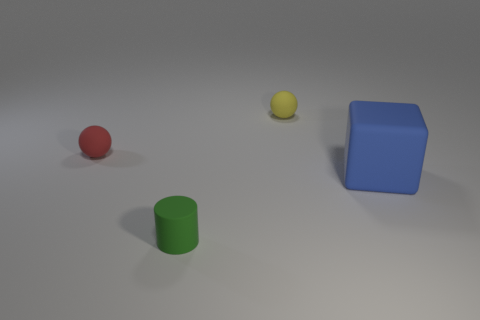What number of other things are there of the same size as the red sphere?
Your answer should be very brief. 2. How many small yellow rubber objects are there?
Provide a succinct answer. 1. Is the size of the red matte object the same as the yellow rubber object?
Your response must be concise. Yes. What number of other things are the same shape as the big matte thing?
Your answer should be compact. 0. Are there any spheres to the left of the large matte block?
Give a very brief answer. Yes. There is a yellow matte sphere; is it the same size as the thing that is in front of the blue cube?
Provide a short and direct response. Yes. The red matte object that is the same shape as the yellow thing is what size?
Provide a short and direct response. Small. There is a sphere right of the tiny red matte object; is it the same size as the object in front of the big blue block?
Keep it short and to the point. Yes. What number of tiny objects are matte blocks or rubber things?
Give a very brief answer. 3. How many objects are both on the left side of the big blue object and in front of the red matte ball?
Offer a terse response. 1. 